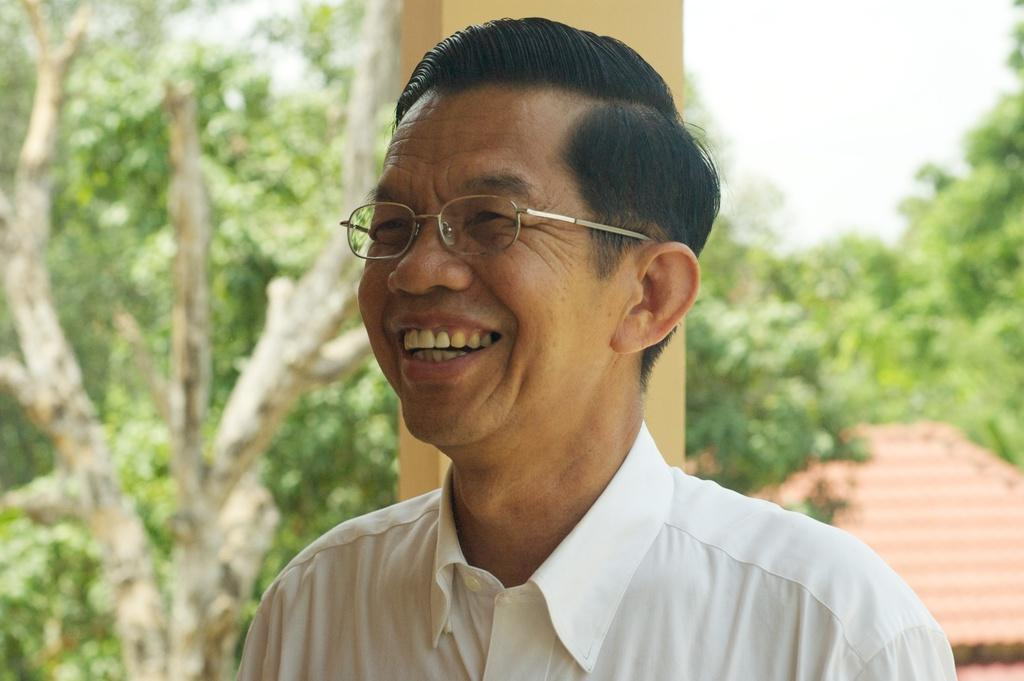What is the main subject of the image? The main subject of the image is a man. Can you describe the man's attire? The man is wearing a white shirt. Does the man have any accessories in the image? Yes, the man is wearing specs. What is the man's facial expression in the image? The man is smiling. How is the man positioned in the image? The man is looking straight in the image. What can be seen in the background of the image? There are trees and a shed house visible in the background of the image. What is the cause of the man's tongue sticking out in the image? The man's tongue is not sticking out in the image; he is smiling and looking straight. What team does the man belong to in the image? There is no indication of the man belonging to a team in the image. 